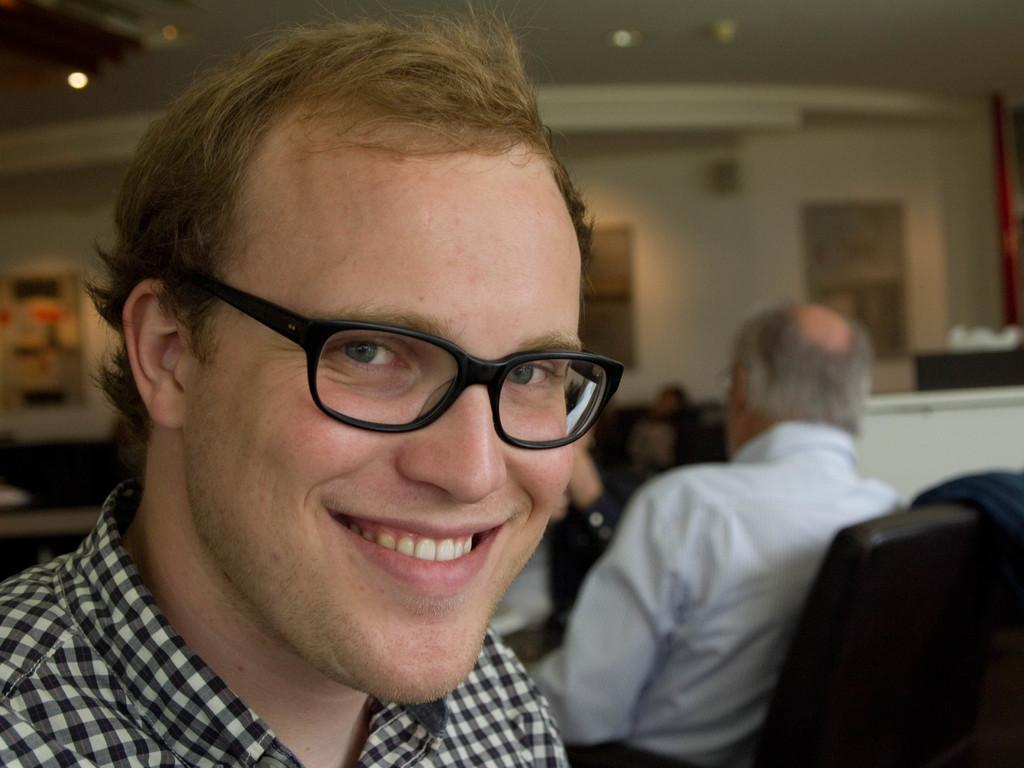How many people are in the image? There are people in the image, but the exact number is not specified. Can you describe any specific features of one of the people? Yes, one person is wearing glasses. What is the position of one of the people in the image? There is a person sitting on a chair. What can be seen in the background of the image? There are lights and stands visible in the background of the image. What type of bears can be seen playing with a bead in the image? There are no bears or beads present in the image. Can you tell me how many scissors are visible in the image? The provided facts do not mention any scissors in the image. 